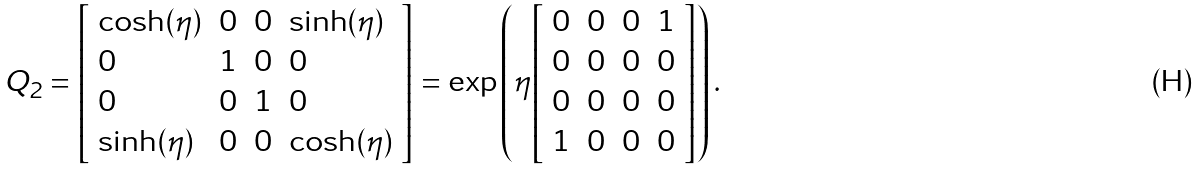Convert formula to latex. <formula><loc_0><loc_0><loc_500><loc_500>Q _ { 2 } = { \left [ \begin{array} { l l l l } { \cosh ( \eta ) } & { 0 } & { 0 } & { \sinh ( \eta ) } \\ { 0 } & { 1 } & { 0 } & { 0 } \\ { 0 } & { 0 } & { 1 } & { 0 } \\ { \sinh ( \eta ) } & { 0 } & { 0 } & { \cosh ( \eta ) } \end{array} \right ] } = \exp \left ( \eta { \left [ \begin{array} { l l l l } { 0 } & { 0 } & { 0 } & { 1 } \\ { 0 } & { 0 } & { 0 } & { 0 } \\ { 0 } & { 0 } & { 0 } & { 0 } \\ { 1 } & { 0 } & { 0 } & { 0 } \end{array} \right ] } \right ) .</formula> 